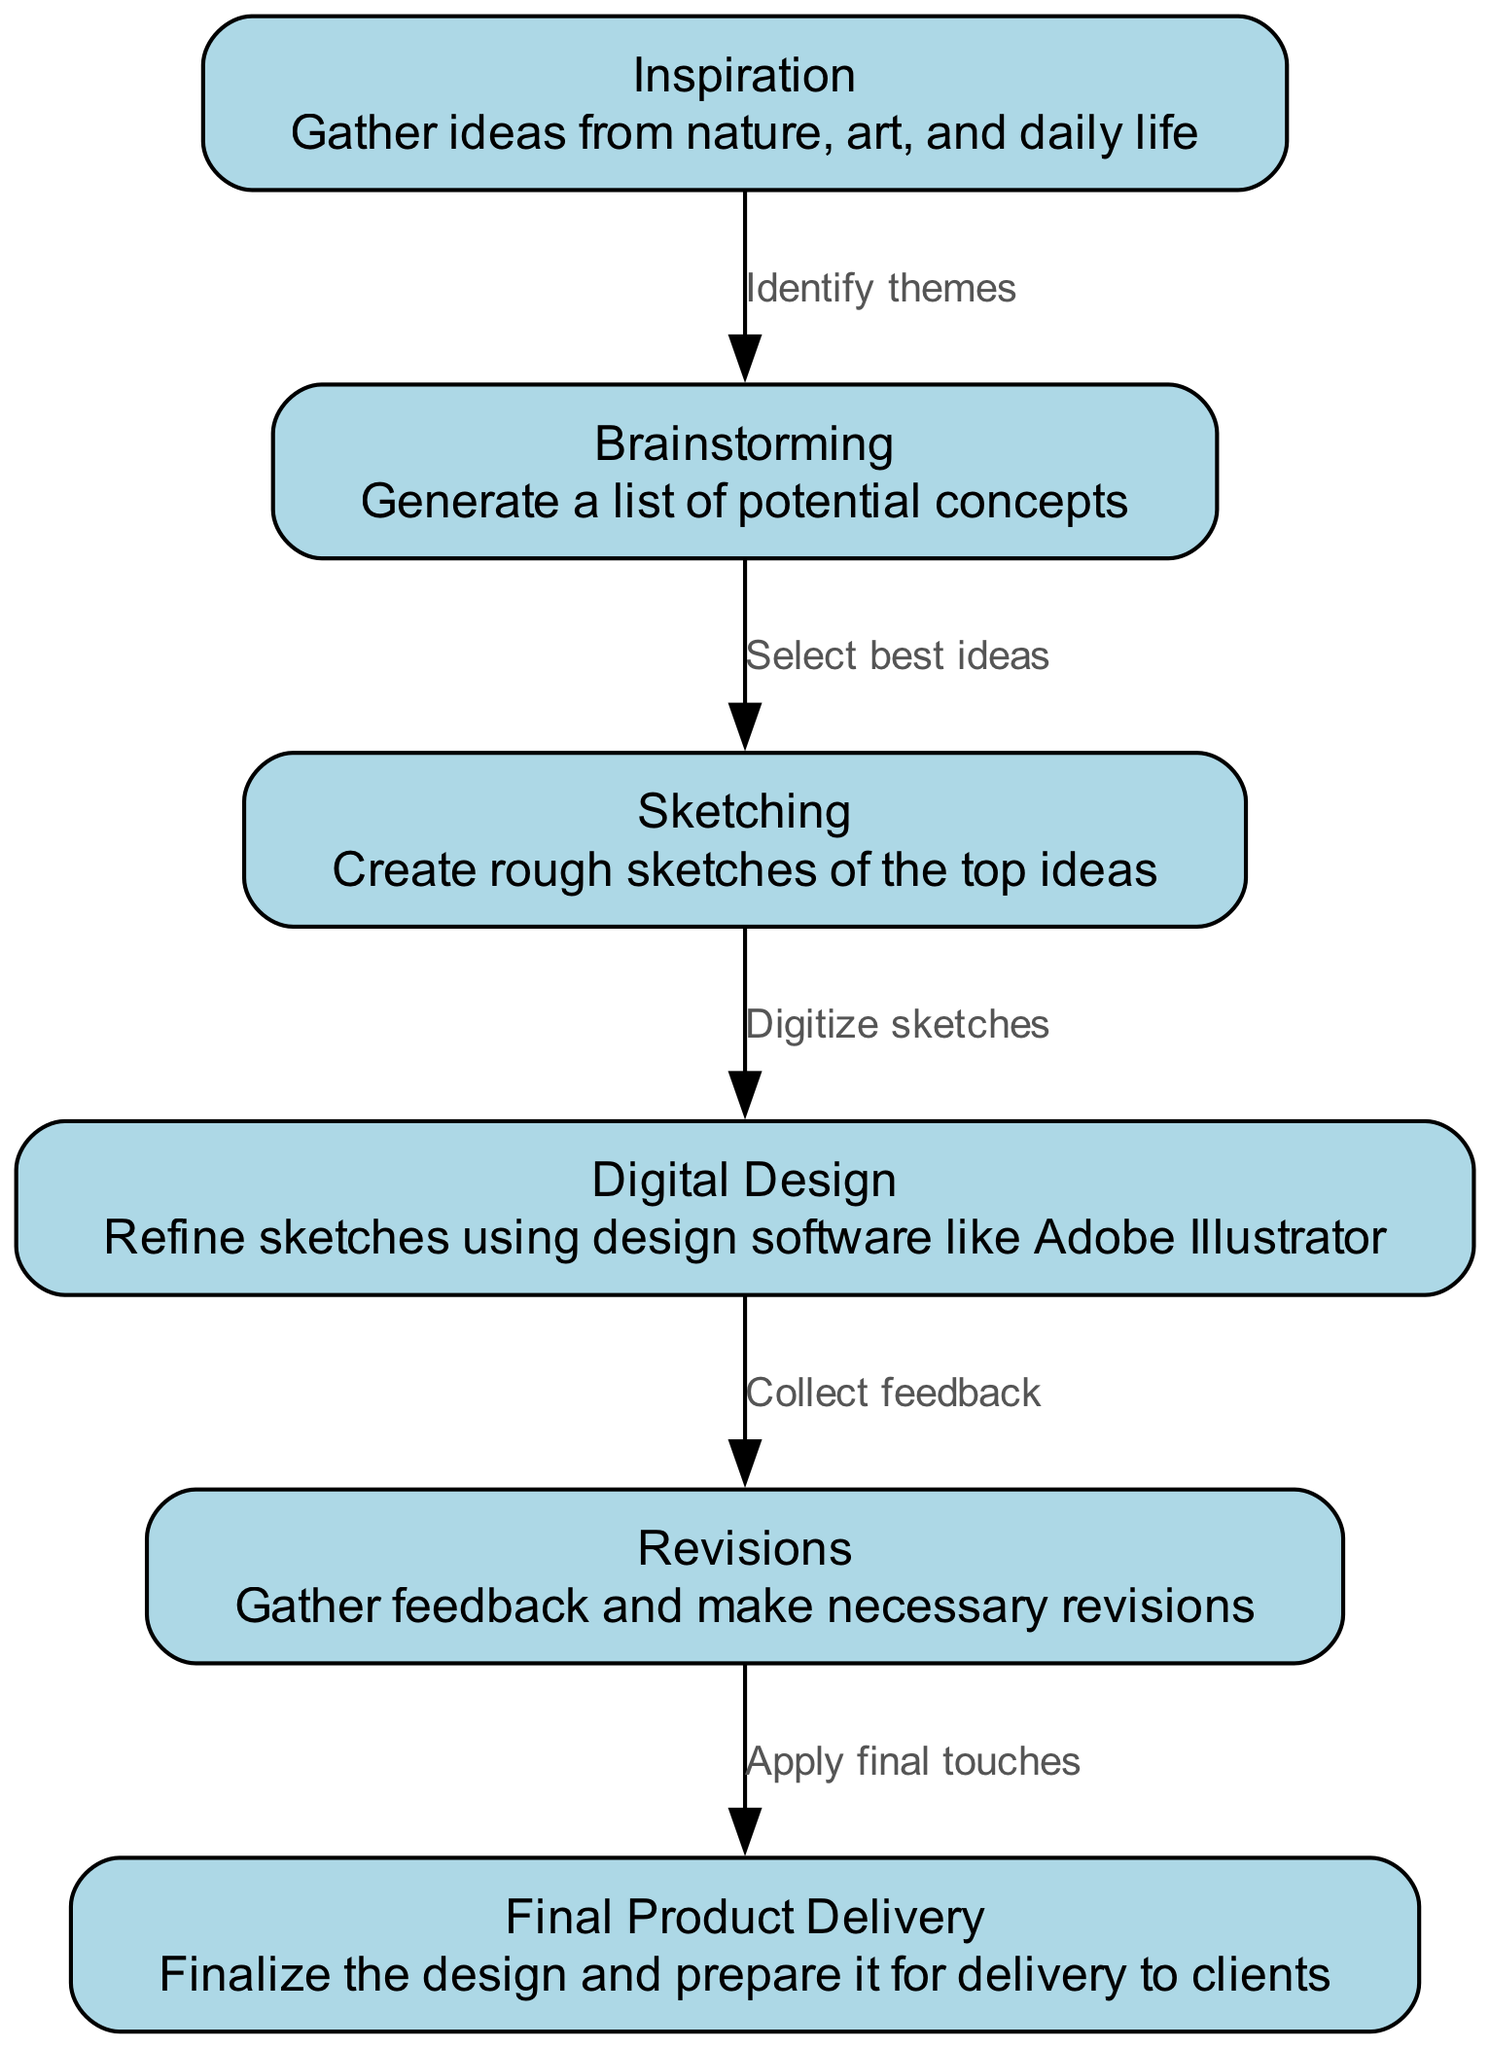What is the first node in the diagram? The first node is labeled "Inspiration," which is the starting point of the creative process.
Answer: Inspiration How many nodes are there in total? Counting all the nodes listed in the diagram, there are six distinct stages in the creative process.
Answer: 6 What label connects 'Brainstorming' and 'Sketching'? The label that connects these two nodes is "Select best ideas," indicating the decision-making process after brainstorming.
Answer: Select best ideas Which node comes after 'Digital Design'? The node that follows 'Digital Design' is 'Revisions,' representing the feedback process before finalization.
Answer: Revisions How many edges are present in the diagram? There are five edges listed, representing the connections and flow between the six nodes.
Answer: 5 What is the relationship between 'Revisions' and 'Final Product Delivery'? The relationship between these two nodes is defined by the label "Apply final touches," indicating the final steps before delivering the product.
Answer: Apply final touches Which node provides feedback for 'Digital Design'? The node that provides feedback for 'Digital Design' is 'Revisions,' where feedback is gathered to improve the design.
Answer: Revisions What is the last stage in the creative process? The last stage in the creative process is 'Final Product Delivery,' where the design is completed and prepared for clients.
Answer: Final Product Delivery What does the node 'Sketching' entail? The 'Sketching' node involves creating rough sketches of the top ideas developed during brainstorming.
Answer: Create rough sketches of the top ideas 